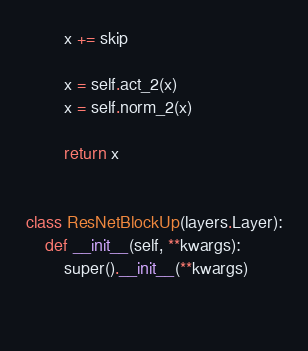<code> <loc_0><loc_0><loc_500><loc_500><_Python_>        x += skip

        x = self.act_2(x)
        x = self.norm_2(x)

        return x


class ResNetBlockUp(layers.Layer):
    def __init__(self, **kwargs):
        super().__init__(**kwargs)

        


</code> 